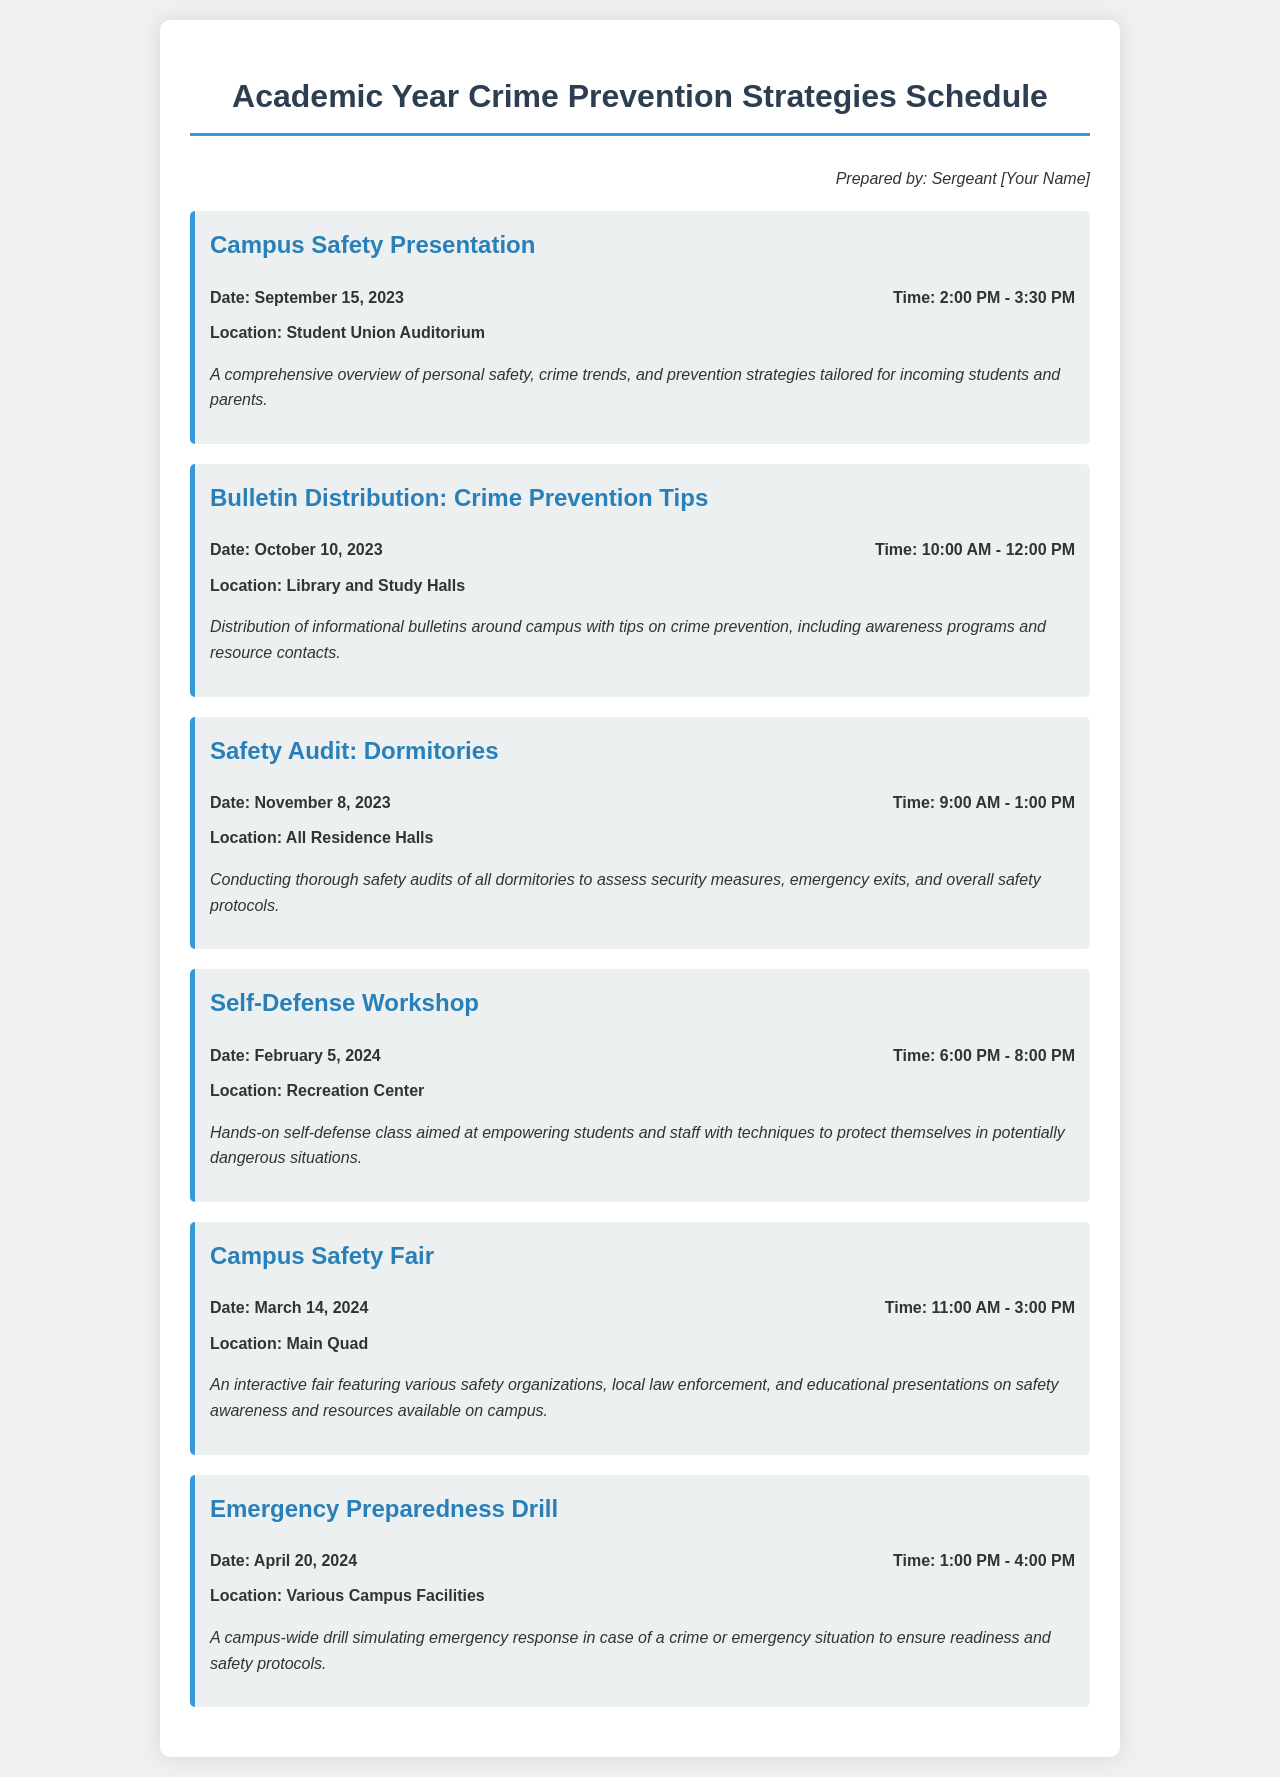What is the date of the Campus Safety Presentation? The date is explicitly mentioned in the event details of the Campus Safety Presentation.
Answer: September 15, 2023 Where is the Self-Defense Workshop taking place? The location is specified in the event details related to the Self-Defense Workshop.
Answer: Recreation Center What time does the Emergency Preparedness Drill start? The start time is listed in the event details for the Emergency Preparedness Drill.
Answer: 1:00 PM How long is the Campus Safety Fair scheduled to last? The duration can be calculated by subtracting the start time from the end time given in the event details.
Answer: 4 hours Which type of event occurs on October 10, 2023? The event type is specified in the title of the event on that date.
Answer: Bulletin Distribution What are the main activities covered in the schedule? The schedule includes various activities like presentations, distributions, and audits, which are detailed throughout the document.
Answer: Presentations, bulletin distributions, safety audits How many hours is the Campus Safety Presentation? The duration of the presentation can be calculated from the specified start and end times in the event details.
Answer: 1.5 hours What is the focus of the Safety Audit scheduled for November 8, 2023? The focus is outlined in the description of the Safety Audit event.
Answer: Dormitories What is the purpose of the Campus Safety Fair? The main purpose is explained in the description of the event.
Answer: Safety awareness and resources available on campus 